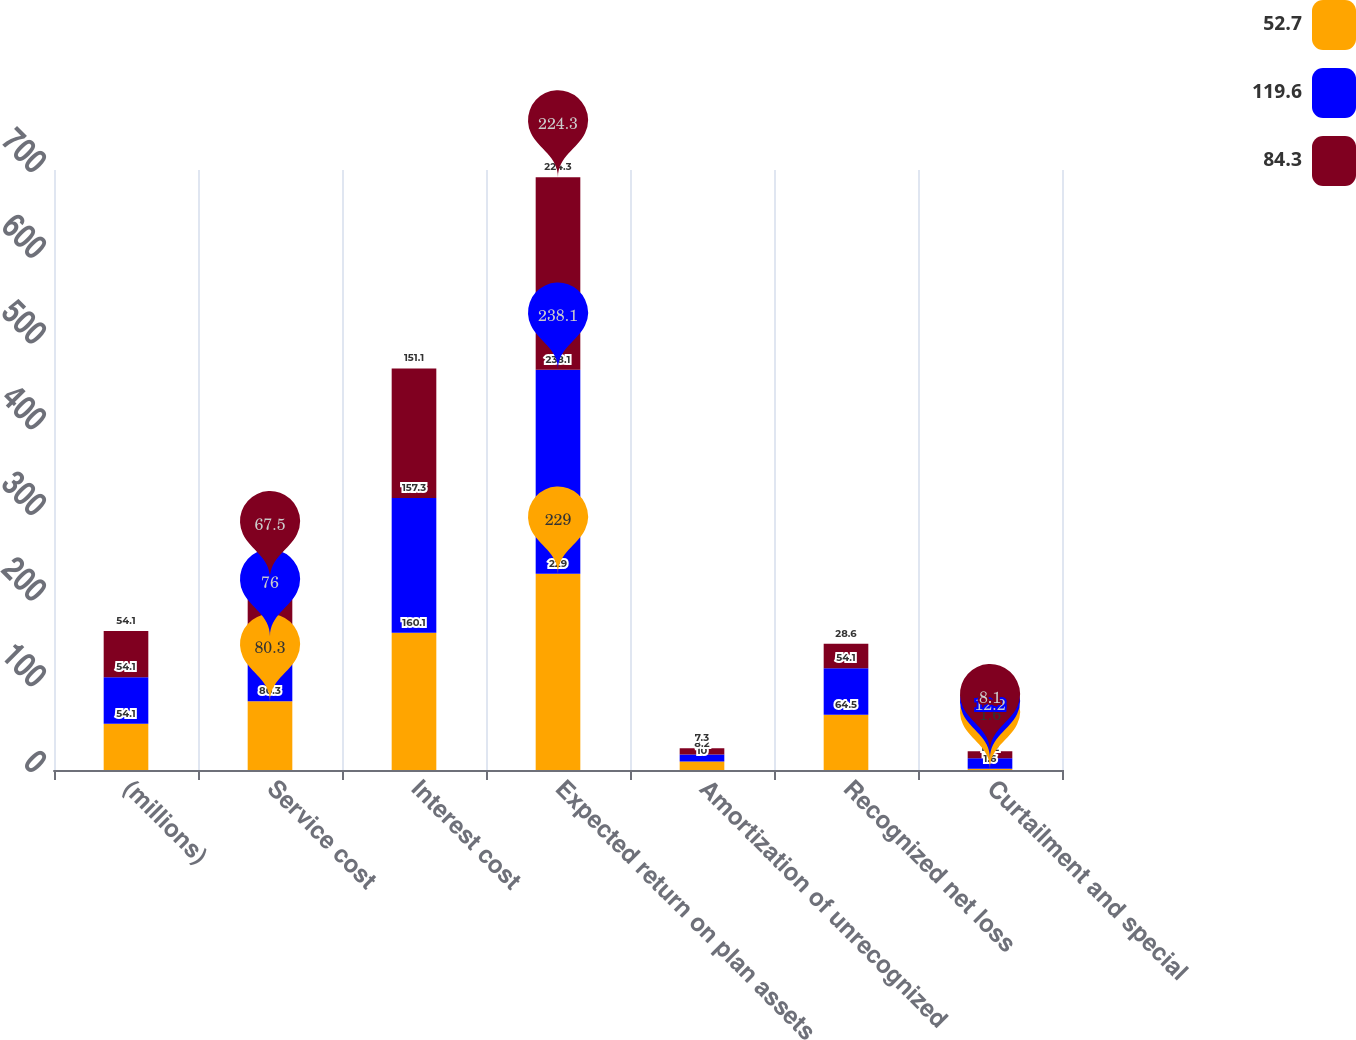Convert chart to OTSL. <chart><loc_0><loc_0><loc_500><loc_500><stacked_bar_chart><ecel><fcel>(millions)<fcel>Service cost<fcel>Interest cost<fcel>Expected return on plan assets<fcel>Amortization of unrecognized<fcel>Recognized net loss<fcel>Curtailment and special<nl><fcel>52.7<fcel>54.1<fcel>80.3<fcel>160.1<fcel>229<fcel>10<fcel>64.5<fcel>1.6<nl><fcel>119.6<fcel>54.1<fcel>76<fcel>157.3<fcel>238.1<fcel>8.2<fcel>54.1<fcel>12.2<nl><fcel>84.3<fcel>54.1<fcel>67.5<fcel>151.1<fcel>224.3<fcel>7.3<fcel>28.6<fcel>8.1<nl></chart> 